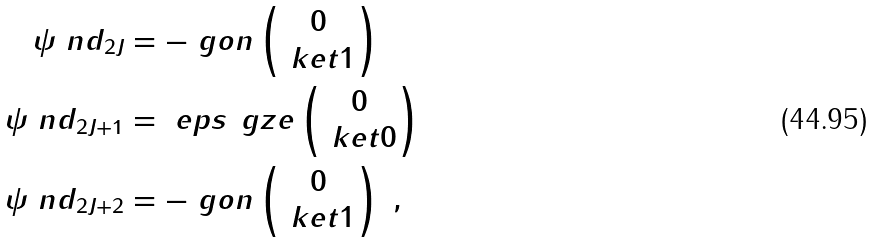<formula> <loc_0><loc_0><loc_500><loc_500>\psi \ n d _ { 2 J } & = - \ g o n \begin{pmatrix} 0 \\ \ k e t { 1 } \end{pmatrix} \\ \psi \ n d _ { 2 J + 1 } & = \ e p s \, \ g z e \begin{pmatrix} 0 \\ \ k e t { 0 } \end{pmatrix} \\ \psi \ n d _ { 2 J + 2 } & = - \ g o n \begin{pmatrix} 0 \\ \ k e t { 1 } \end{pmatrix} \ ,</formula> 